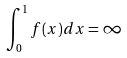<formula> <loc_0><loc_0><loc_500><loc_500>\int _ { 0 } ^ { 1 } f ( x ) d x = \infty</formula> 